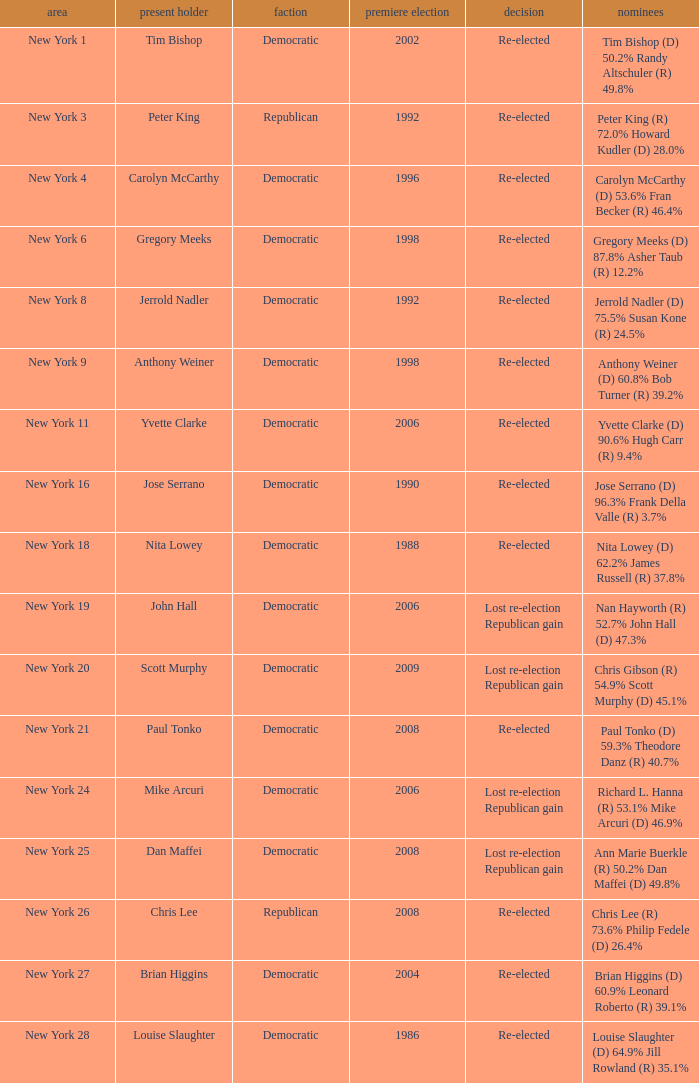Name the result for new york 8 Re-elected. 